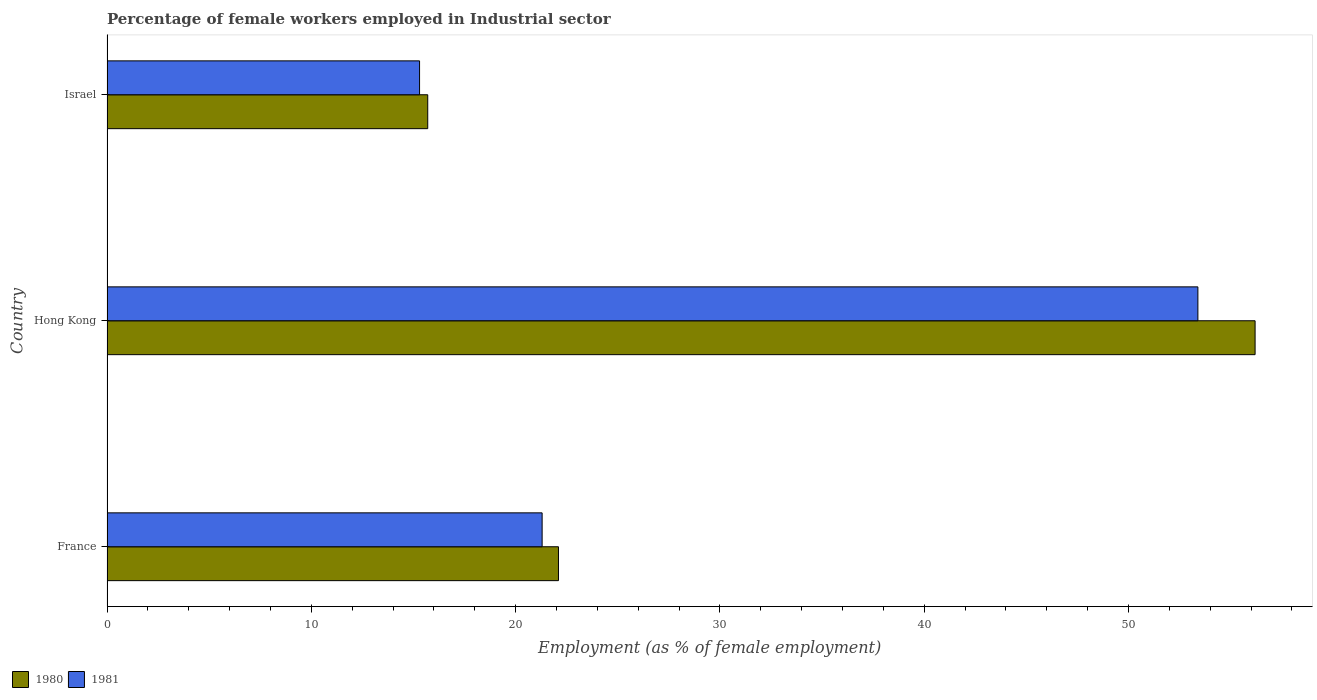How many different coloured bars are there?
Ensure brevity in your answer.  2. Are the number of bars per tick equal to the number of legend labels?
Offer a terse response. Yes. How many bars are there on the 2nd tick from the bottom?
Your answer should be compact. 2. What is the label of the 2nd group of bars from the top?
Your response must be concise. Hong Kong. In how many cases, is the number of bars for a given country not equal to the number of legend labels?
Offer a very short reply. 0. What is the percentage of females employed in Industrial sector in 1981 in Hong Kong?
Your response must be concise. 53.4. Across all countries, what is the maximum percentage of females employed in Industrial sector in 1980?
Provide a short and direct response. 56.2. Across all countries, what is the minimum percentage of females employed in Industrial sector in 1980?
Your answer should be compact. 15.7. In which country was the percentage of females employed in Industrial sector in 1980 maximum?
Provide a succinct answer. Hong Kong. What is the total percentage of females employed in Industrial sector in 1980 in the graph?
Provide a short and direct response. 94. What is the difference between the percentage of females employed in Industrial sector in 1981 in France and that in Hong Kong?
Ensure brevity in your answer.  -32.1. What is the difference between the percentage of females employed in Industrial sector in 1981 in Israel and the percentage of females employed in Industrial sector in 1980 in France?
Your response must be concise. -6.8. What is the average percentage of females employed in Industrial sector in 1981 per country?
Make the answer very short. 30. What is the difference between the percentage of females employed in Industrial sector in 1981 and percentage of females employed in Industrial sector in 1980 in Israel?
Make the answer very short. -0.4. In how many countries, is the percentage of females employed in Industrial sector in 1981 greater than 42 %?
Give a very brief answer. 1. What is the ratio of the percentage of females employed in Industrial sector in 1980 in France to that in Israel?
Your answer should be compact. 1.41. Is the percentage of females employed in Industrial sector in 1980 in France less than that in Israel?
Provide a succinct answer. No. Is the difference between the percentage of females employed in Industrial sector in 1981 in France and Hong Kong greater than the difference between the percentage of females employed in Industrial sector in 1980 in France and Hong Kong?
Keep it short and to the point. Yes. What is the difference between the highest and the second highest percentage of females employed in Industrial sector in 1980?
Make the answer very short. 34.1. What is the difference between the highest and the lowest percentage of females employed in Industrial sector in 1981?
Provide a short and direct response. 38.1. What does the 1st bar from the bottom in Hong Kong represents?
Your response must be concise. 1980. Does the graph contain grids?
Make the answer very short. No. Where does the legend appear in the graph?
Your response must be concise. Bottom left. How are the legend labels stacked?
Offer a very short reply. Horizontal. What is the title of the graph?
Offer a terse response. Percentage of female workers employed in Industrial sector. What is the label or title of the X-axis?
Provide a succinct answer. Employment (as % of female employment). What is the label or title of the Y-axis?
Provide a short and direct response. Country. What is the Employment (as % of female employment) of 1980 in France?
Ensure brevity in your answer.  22.1. What is the Employment (as % of female employment) of 1981 in France?
Ensure brevity in your answer.  21.3. What is the Employment (as % of female employment) of 1980 in Hong Kong?
Make the answer very short. 56.2. What is the Employment (as % of female employment) in 1981 in Hong Kong?
Keep it short and to the point. 53.4. What is the Employment (as % of female employment) of 1980 in Israel?
Your response must be concise. 15.7. What is the Employment (as % of female employment) in 1981 in Israel?
Ensure brevity in your answer.  15.3. Across all countries, what is the maximum Employment (as % of female employment) of 1980?
Make the answer very short. 56.2. Across all countries, what is the maximum Employment (as % of female employment) of 1981?
Your response must be concise. 53.4. Across all countries, what is the minimum Employment (as % of female employment) of 1980?
Provide a short and direct response. 15.7. Across all countries, what is the minimum Employment (as % of female employment) in 1981?
Give a very brief answer. 15.3. What is the total Employment (as % of female employment) of 1980 in the graph?
Make the answer very short. 94. What is the difference between the Employment (as % of female employment) of 1980 in France and that in Hong Kong?
Ensure brevity in your answer.  -34.1. What is the difference between the Employment (as % of female employment) in 1981 in France and that in Hong Kong?
Keep it short and to the point. -32.1. What is the difference between the Employment (as % of female employment) of 1981 in France and that in Israel?
Offer a very short reply. 6. What is the difference between the Employment (as % of female employment) of 1980 in Hong Kong and that in Israel?
Offer a terse response. 40.5. What is the difference between the Employment (as % of female employment) of 1981 in Hong Kong and that in Israel?
Your answer should be very brief. 38.1. What is the difference between the Employment (as % of female employment) in 1980 in France and the Employment (as % of female employment) in 1981 in Hong Kong?
Keep it short and to the point. -31.3. What is the difference between the Employment (as % of female employment) in 1980 in Hong Kong and the Employment (as % of female employment) in 1981 in Israel?
Keep it short and to the point. 40.9. What is the average Employment (as % of female employment) in 1980 per country?
Give a very brief answer. 31.33. What is the average Employment (as % of female employment) of 1981 per country?
Your answer should be compact. 30. What is the difference between the Employment (as % of female employment) of 1980 and Employment (as % of female employment) of 1981 in Hong Kong?
Ensure brevity in your answer.  2.8. What is the difference between the Employment (as % of female employment) of 1980 and Employment (as % of female employment) of 1981 in Israel?
Keep it short and to the point. 0.4. What is the ratio of the Employment (as % of female employment) in 1980 in France to that in Hong Kong?
Make the answer very short. 0.39. What is the ratio of the Employment (as % of female employment) of 1981 in France to that in Hong Kong?
Your answer should be very brief. 0.4. What is the ratio of the Employment (as % of female employment) of 1980 in France to that in Israel?
Your answer should be compact. 1.41. What is the ratio of the Employment (as % of female employment) of 1981 in France to that in Israel?
Keep it short and to the point. 1.39. What is the ratio of the Employment (as % of female employment) in 1980 in Hong Kong to that in Israel?
Your answer should be compact. 3.58. What is the ratio of the Employment (as % of female employment) of 1981 in Hong Kong to that in Israel?
Provide a succinct answer. 3.49. What is the difference between the highest and the second highest Employment (as % of female employment) in 1980?
Keep it short and to the point. 34.1. What is the difference between the highest and the second highest Employment (as % of female employment) in 1981?
Make the answer very short. 32.1. What is the difference between the highest and the lowest Employment (as % of female employment) in 1980?
Offer a terse response. 40.5. What is the difference between the highest and the lowest Employment (as % of female employment) of 1981?
Offer a terse response. 38.1. 